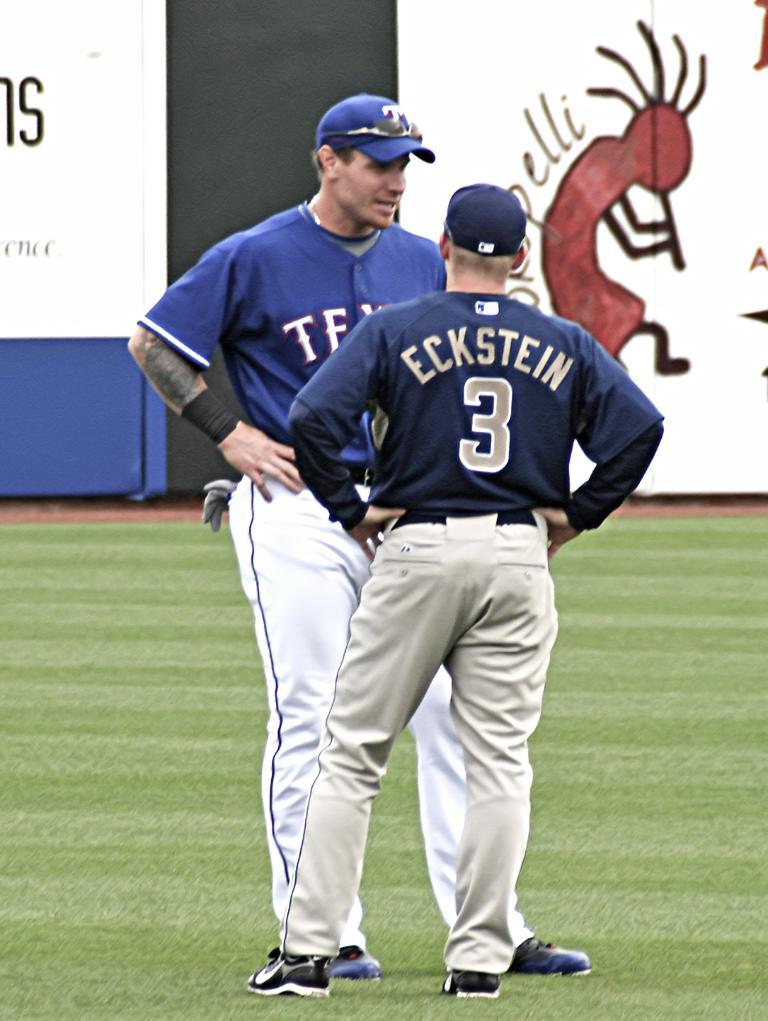<image>
Share a concise interpretation of the image provided. Two baseball players talking to each other, one of which is number 3 